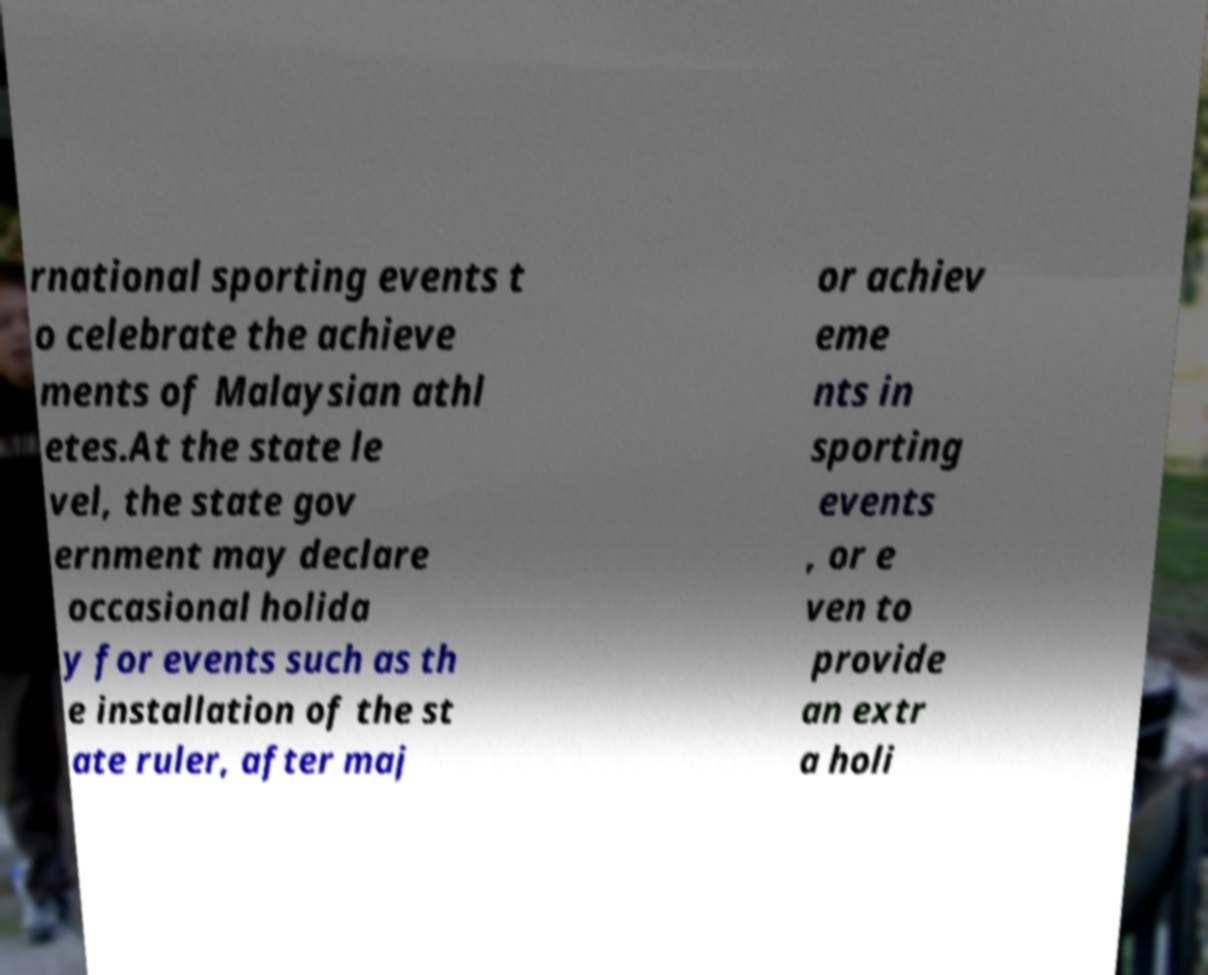What messages or text are displayed in this image? I need them in a readable, typed format. rnational sporting events t o celebrate the achieve ments of Malaysian athl etes.At the state le vel, the state gov ernment may declare occasional holida y for events such as th e installation of the st ate ruler, after maj or achiev eme nts in sporting events , or e ven to provide an extr a holi 